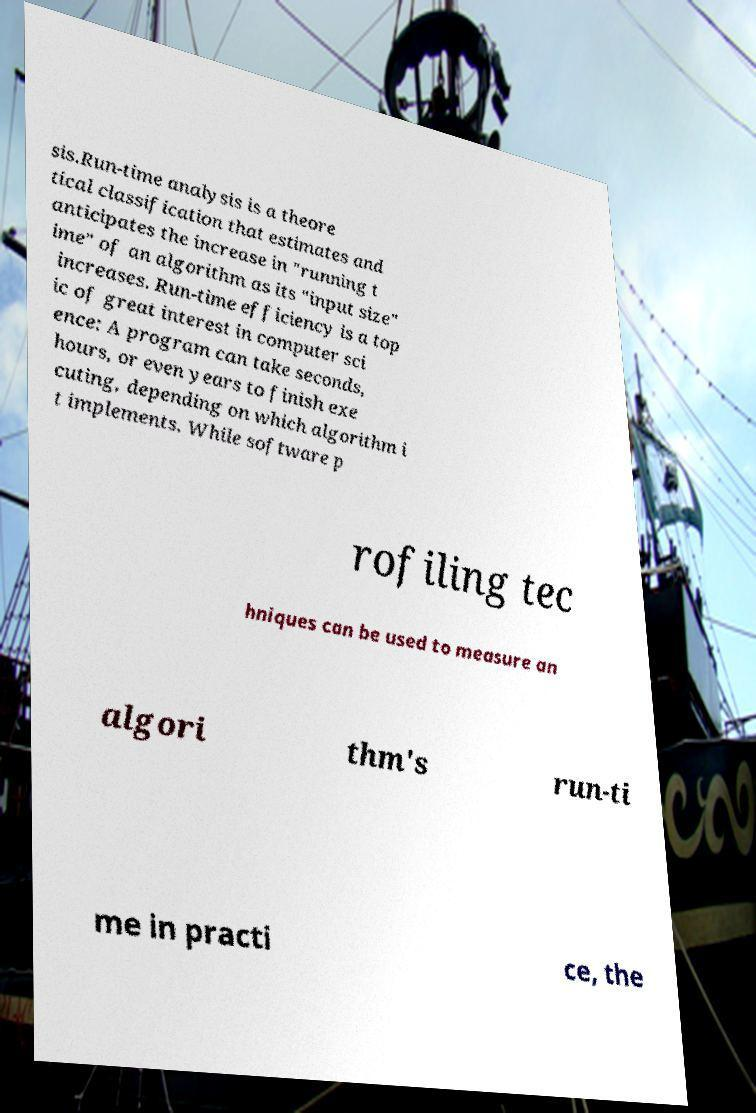Could you assist in decoding the text presented in this image and type it out clearly? sis.Run-time analysis is a theore tical classification that estimates and anticipates the increase in "running t ime" of an algorithm as its "input size" increases. Run-time efficiency is a top ic of great interest in computer sci ence: A program can take seconds, hours, or even years to finish exe cuting, depending on which algorithm i t implements. While software p rofiling tec hniques can be used to measure an algori thm's run-ti me in practi ce, the 